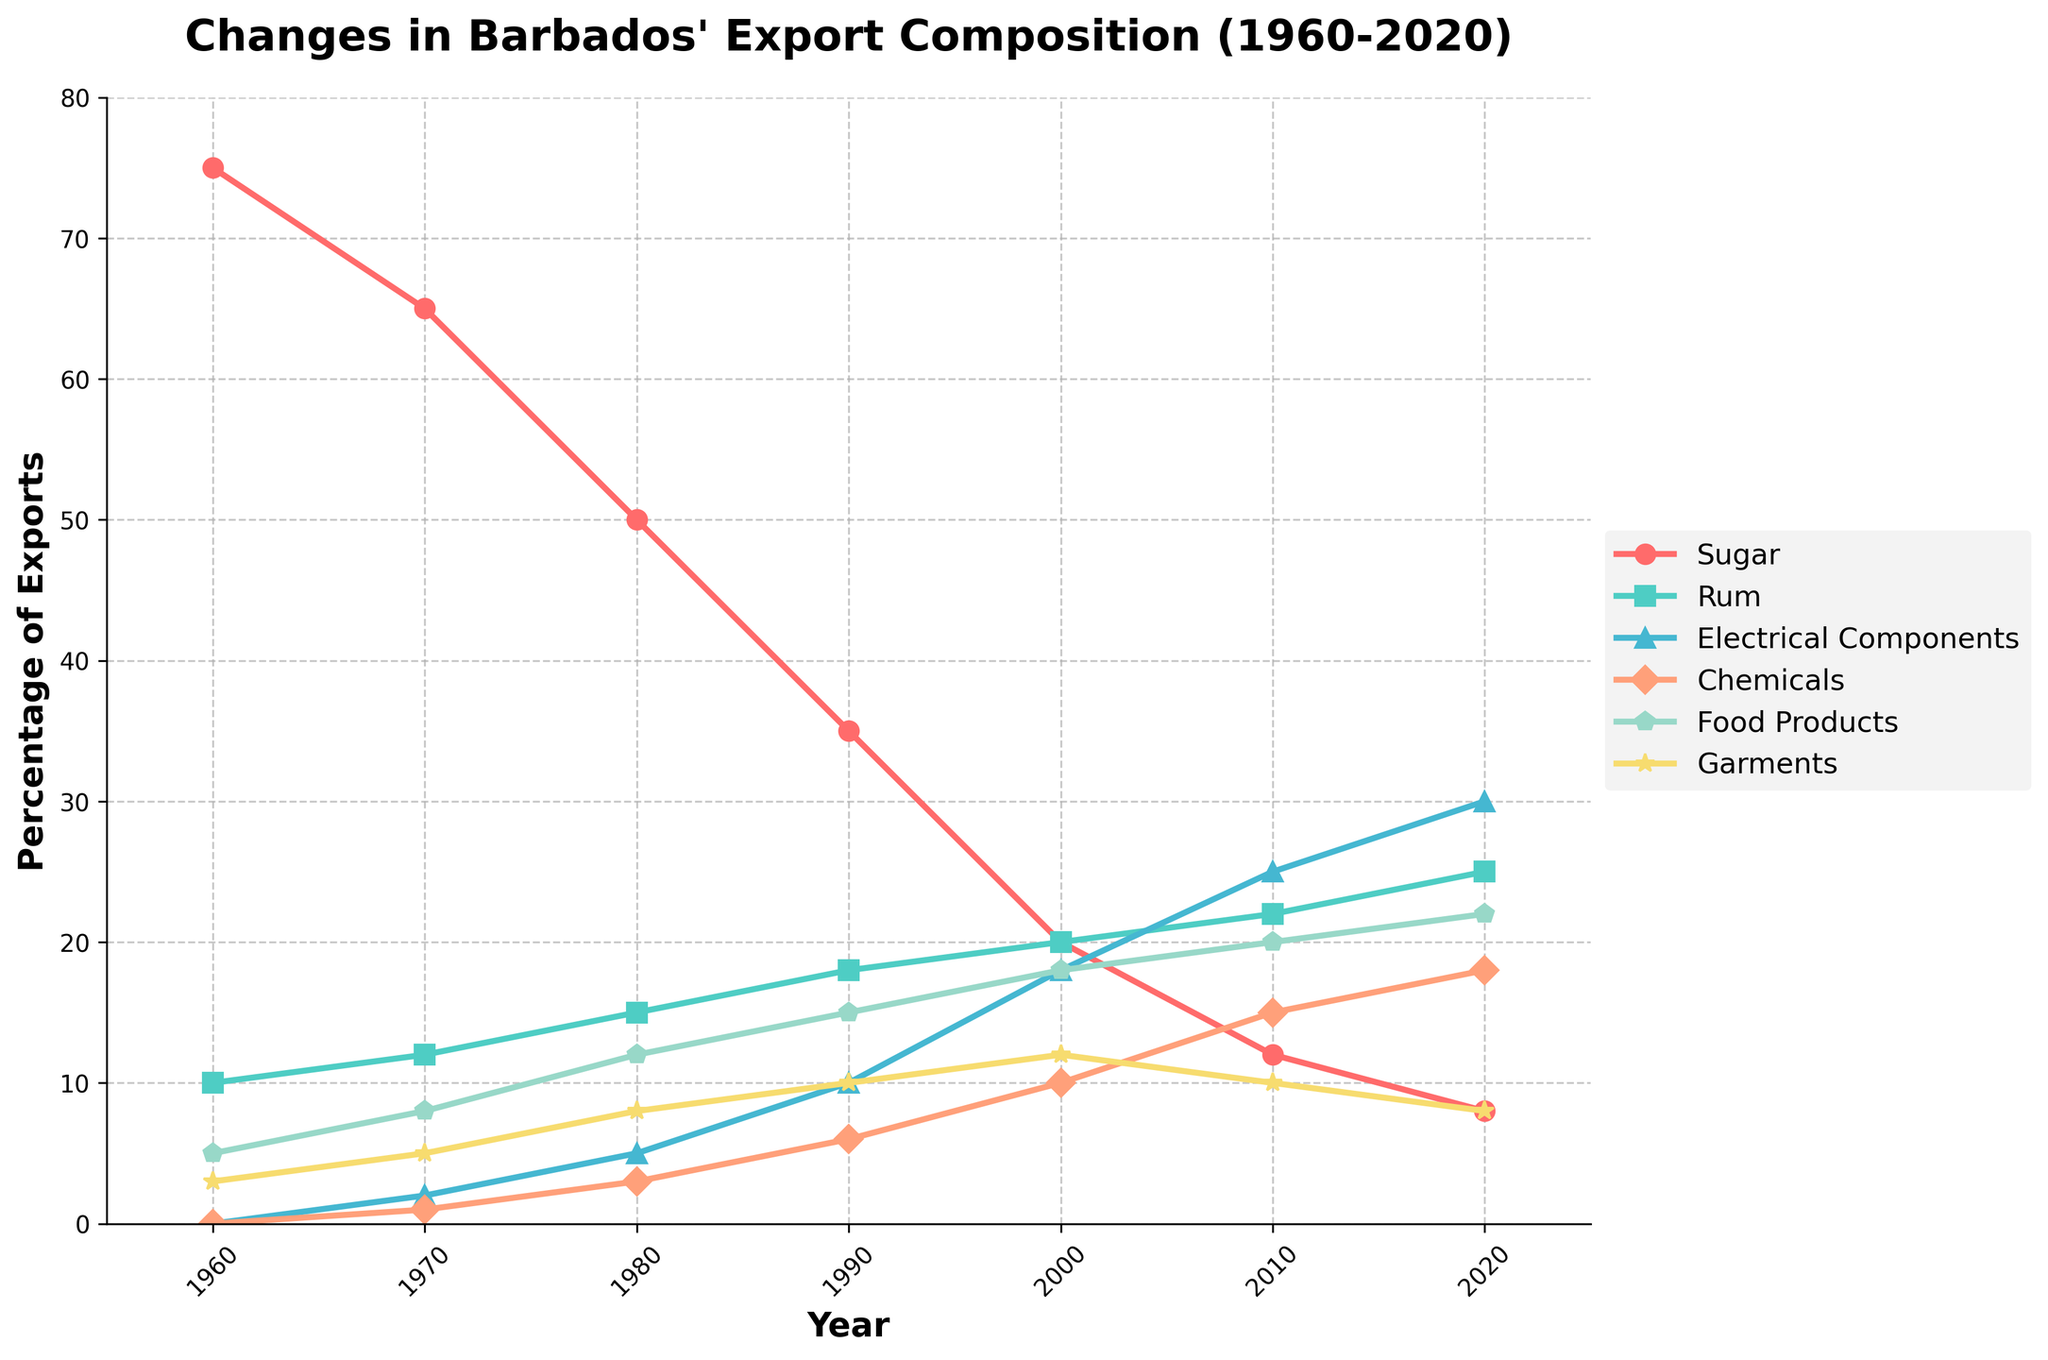What are the top three export products in 1960? By looking at the 1960 data points, we see that Sugar was at 75%, Rum at 10%, and Food Products at 5%. These are the highest percentages for that year.
Answer: Sugar, Rum, Food Products How did the percentage of Sugar exports change from 1960 to 2020? In 1960, the percentage of Sugar exports was 75%. By 2020, it had decreased to 8%. The change is 75% - 8% = 67%.
Answer: Decreased by 67% Which product saw the most significant increase in its export share between 1960 and 2020? Examining the changes over this period, Electrical Components increased from 0% in 1960 to 30% in 2020. Other products did not increase by this much.
Answer: Electrical Components Between 1980 and 2020, which product's export share fluctuated the most? Looking at the lines for each product between these years, Electrical Components shows a significant increase from 5% in 1980 to 30% in 2020, indicating the highest fluctuation.
Answer: Electrical Components In which year did Rum surpass Sugar in terms of export percentage, and by how much? By checking year-by-year data points, in 2000, Rum (20%) exceeded Sugar (20%), and the trend continued in subsequent years. In 2020, Rum had 25%, and Sugar had 8%. So, it increased beyond Sugar by 25% - 8% = 17%.
Answer: 2000, Rum increased by 5% What is the median percentage of Rum exports throughout the years depicted? The values of Rum over the years are 10%, 12%, 15%, 18%, 20%, 22%, and 25%. When sorted, the median value is the middle one, which is 18%.
Answer: 18% Which two products had the closest export percentages in 1990, and what were those percentages? In 1990, Rum was 18%, Electrical Components were 10%, and Chemicals were 6%. The closest percentages are for Electrical Components and Chemicals: 10% and 6%.
Answer: Electrical Components (10%), Chemicals (6%) What is the average percentage of Food Products exports between 1960 and 2020? Adding the percentages for Food Products from each year gives us 5 + 8 + 12 + 15 + 18 + 20 + 22 = 100%. There are 7 data points, so the average is 100% / 7 = 14.29%.
Answer: 14.29% In 2010, what is the difference in export percentages between the highest and lowest exported products? In 2010, the highest export percentage is for Electrical Components at 25%, and the lowest is for Garments at 10%. The difference is 25% - 10% = 15%.
Answer: 15% Which export product showed a consistent increase throughout the years from 1960 to 2020? Checking each year, Rum has shown a consistent increase without any decrease or fluctuation from 10% in 1960 to 25% in 2020.
Answer: Rum 